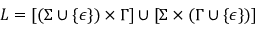Convert formula to latex. <formula><loc_0><loc_0><loc_500><loc_500>L = [ ( \Sigma \cup \{ \epsilon \} ) \times \Gamma ] \cup [ \Sigma \times ( \Gamma \cup \{ \epsilon \} ) ]</formula> 